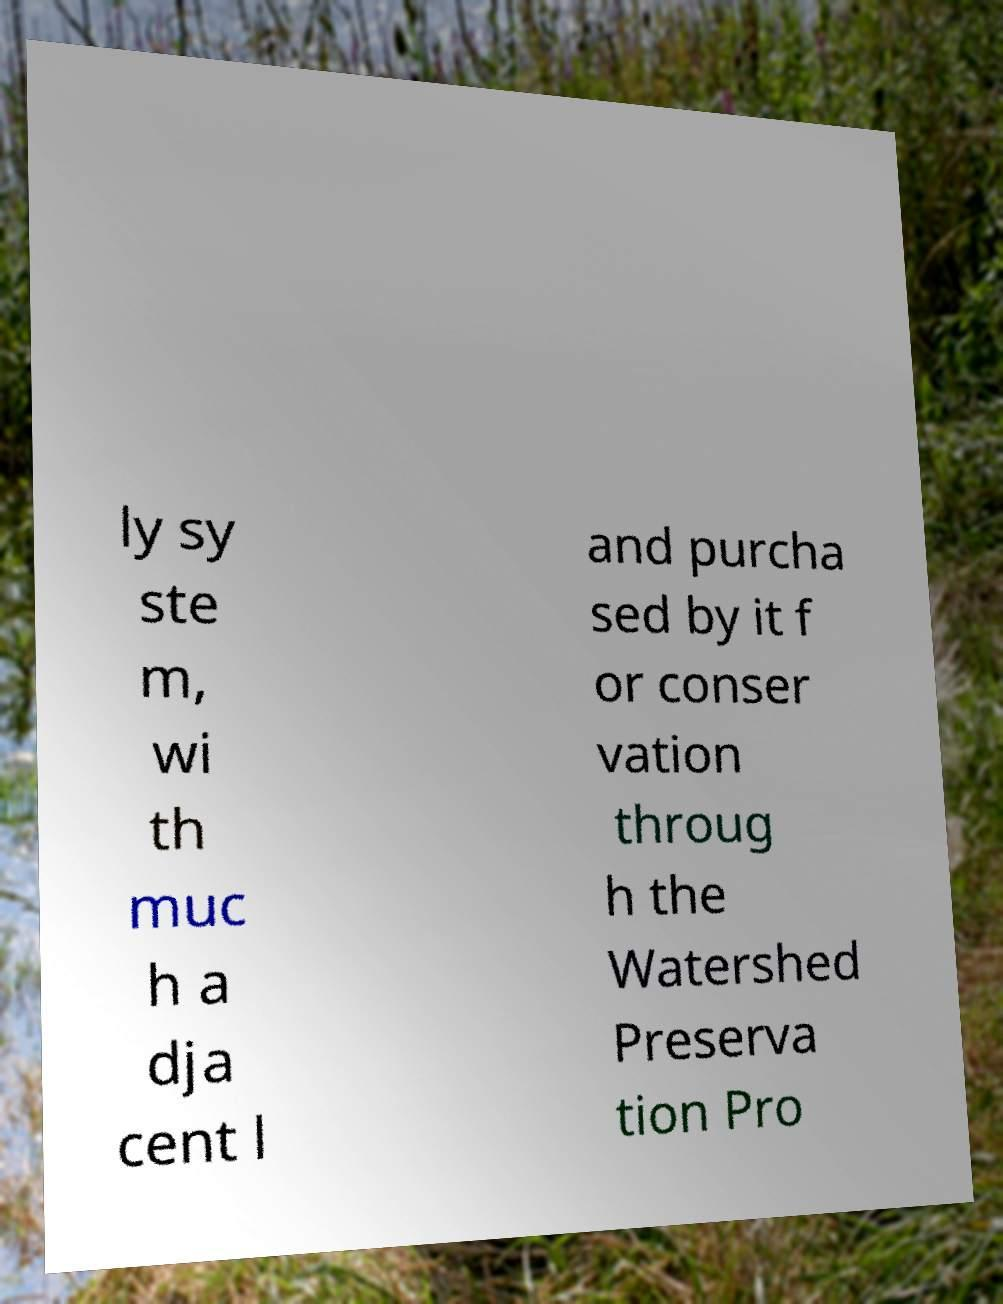There's text embedded in this image that I need extracted. Can you transcribe it verbatim? ly sy ste m, wi th muc h a dja cent l and purcha sed by it f or conser vation throug h the Watershed Preserva tion Pro 